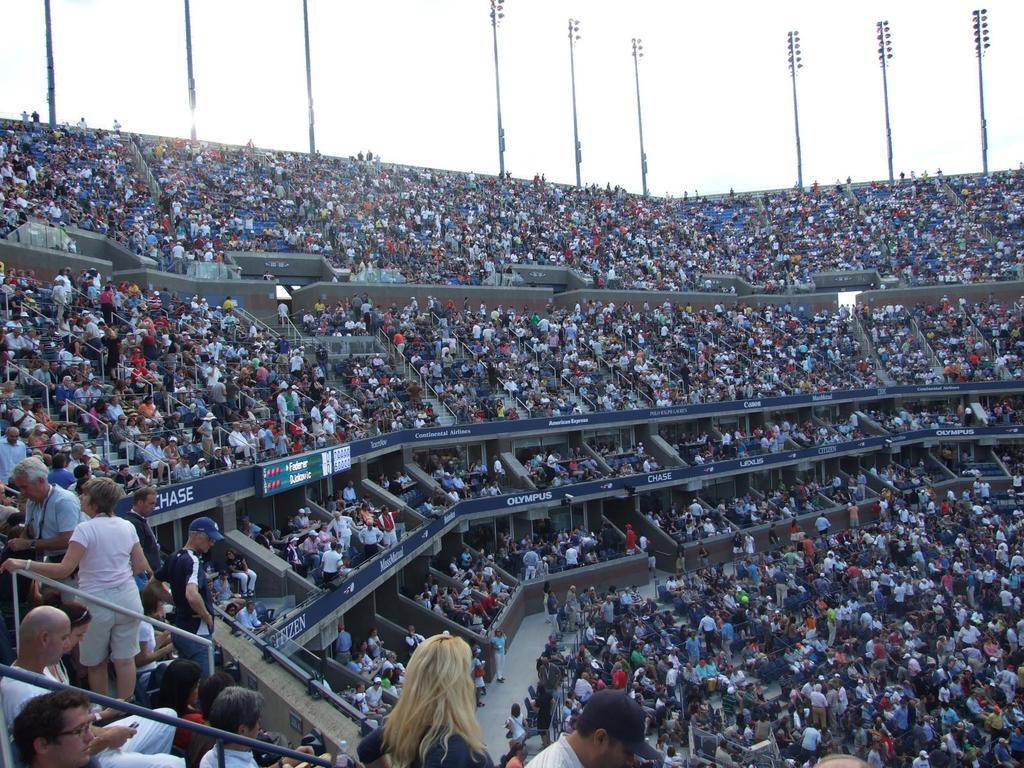What type of structure is the main subject of focus of the image? There is a stadium in the image. How are people positioned within the stadium? Many people are sitting in the stadium, while others are standing at the back. What feature can be seen on the poles in the image? The poles have lights on them. What type of jam can be seen on the shelves in the image? There is no jam or shelves present in the image; it features a stadium with people and poles with lights. 